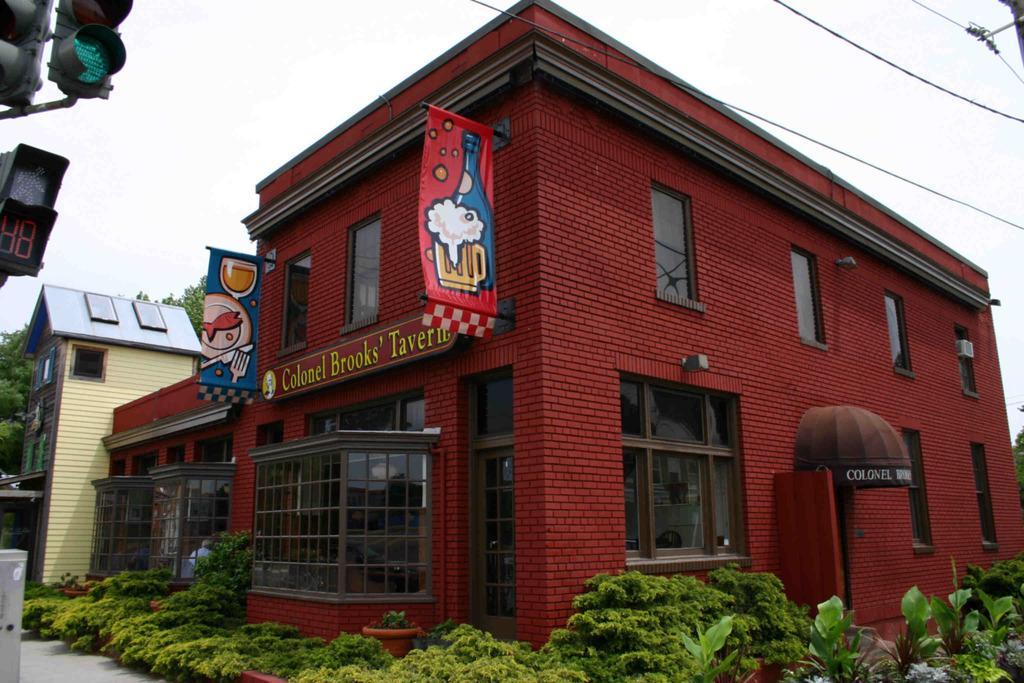In one or two sentences, can you explain what this image depicts? In the center of the image there are buildings and we can see banners. On the left there is a traffic light. At the bottom there are bushes. At the top there are wires and sky. 